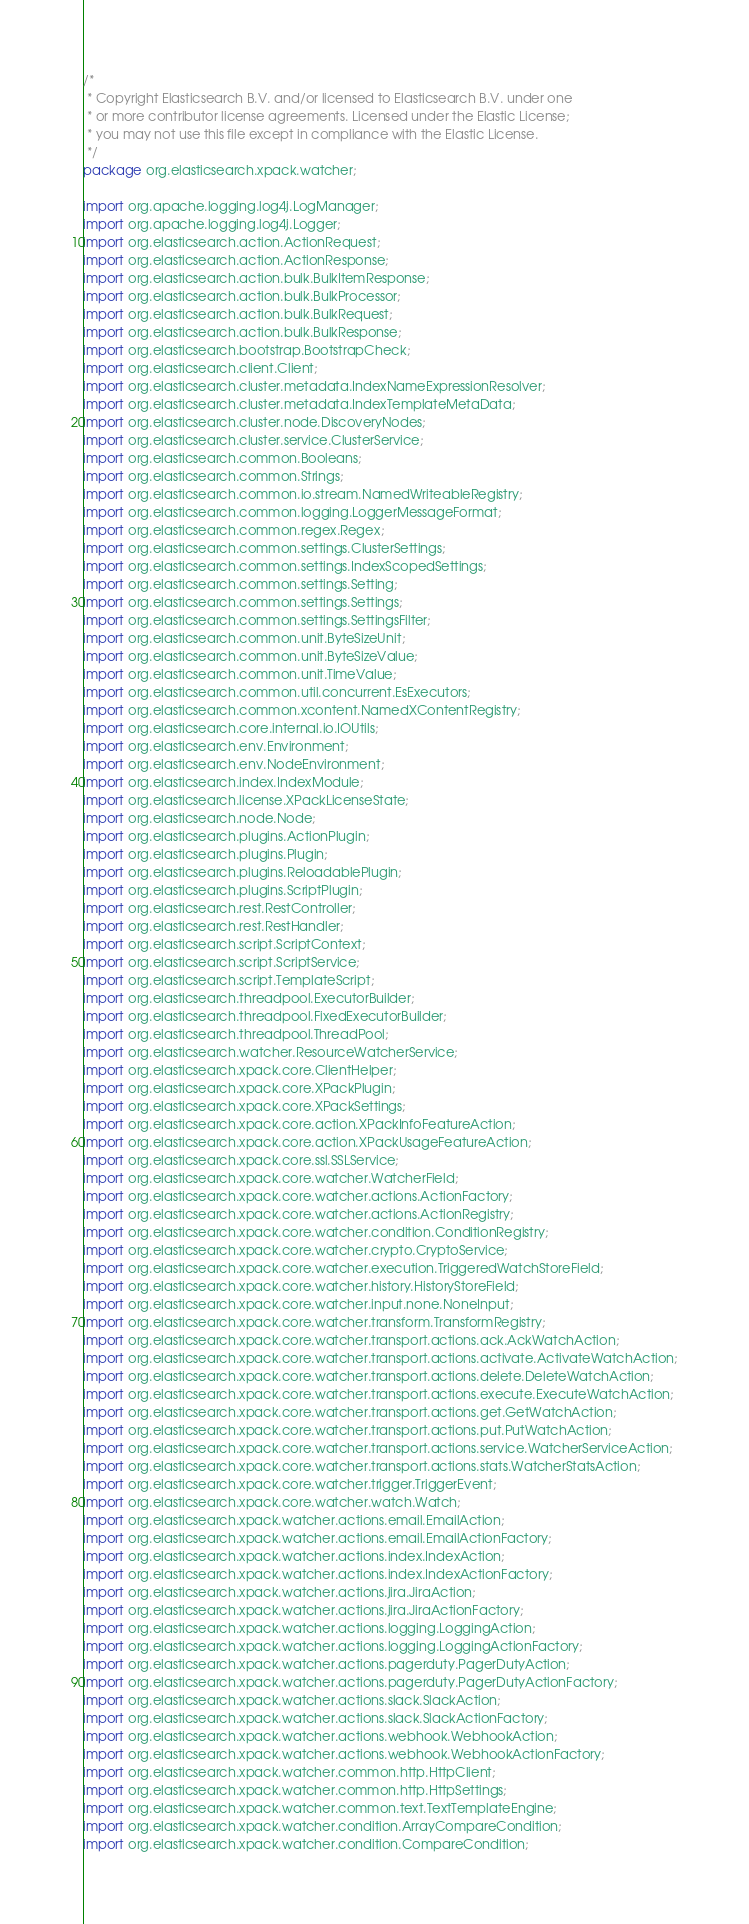Convert code to text. <code><loc_0><loc_0><loc_500><loc_500><_Java_>/*
 * Copyright Elasticsearch B.V. and/or licensed to Elasticsearch B.V. under one
 * or more contributor license agreements. Licensed under the Elastic License;
 * you may not use this file except in compliance with the Elastic License.
 */
package org.elasticsearch.xpack.watcher;

import org.apache.logging.log4j.LogManager;
import org.apache.logging.log4j.Logger;
import org.elasticsearch.action.ActionRequest;
import org.elasticsearch.action.ActionResponse;
import org.elasticsearch.action.bulk.BulkItemResponse;
import org.elasticsearch.action.bulk.BulkProcessor;
import org.elasticsearch.action.bulk.BulkRequest;
import org.elasticsearch.action.bulk.BulkResponse;
import org.elasticsearch.bootstrap.BootstrapCheck;
import org.elasticsearch.client.Client;
import org.elasticsearch.cluster.metadata.IndexNameExpressionResolver;
import org.elasticsearch.cluster.metadata.IndexTemplateMetaData;
import org.elasticsearch.cluster.node.DiscoveryNodes;
import org.elasticsearch.cluster.service.ClusterService;
import org.elasticsearch.common.Booleans;
import org.elasticsearch.common.Strings;
import org.elasticsearch.common.io.stream.NamedWriteableRegistry;
import org.elasticsearch.common.logging.LoggerMessageFormat;
import org.elasticsearch.common.regex.Regex;
import org.elasticsearch.common.settings.ClusterSettings;
import org.elasticsearch.common.settings.IndexScopedSettings;
import org.elasticsearch.common.settings.Setting;
import org.elasticsearch.common.settings.Settings;
import org.elasticsearch.common.settings.SettingsFilter;
import org.elasticsearch.common.unit.ByteSizeUnit;
import org.elasticsearch.common.unit.ByteSizeValue;
import org.elasticsearch.common.unit.TimeValue;
import org.elasticsearch.common.util.concurrent.EsExecutors;
import org.elasticsearch.common.xcontent.NamedXContentRegistry;
import org.elasticsearch.core.internal.io.IOUtils;
import org.elasticsearch.env.Environment;
import org.elasticsearch.env.NodeEnvironment;
import org.elasticsearch.index.IndexModule;
import org.elasticsearch.license.XPackLicenseState;
import org.elasticsearch.node.Node;
import org.elasticsearch.plugins.ActionPlugin;
import org.elasticsearch.plugins.Plugin;
import org.elasticsearch.plugins.ReloadablePlugin;
import org.elasticsearch.plugins.ScriptPlugin;
import org.elasticsearch.rest.RestController;
import org.elasticsearch.rest.RestHandler;
import org.elasticsearch.script.ScriptContext;
import org.elasticsearch.script.ScriptService;
import org.elasticsearch.script.TemplateScript;
import org.elasticsearch.threadpool.ExecutorBuilder;
import org.elasticsearch.threadpool.FixedExecutorBuilder;
import org.elasticsearch.threadpool.ThreadPool;
import org.elasticsearch.watcher.ResourceWatcherService;
import org.elasticsearch.xpack.core.ClientHelper;
import org.elasticsearch.xpack.core.XPackPlugin;
import org.elasticsearch.xpack.core.XPackSettings;
import org.elasticsearch.xpack.core.action.XPackInfoFeatureAction;
import org.elasticsearch.xpack.core.action.XPackUsageFeatureAction;
import org.elasticsearch.xpack.core.ssl.SSLService;
import org.elasticsearch.xpack.core.watcher.WatcherField;
import org.elasticsearch.xpack.core.watcher.actions.ActionFactory;
import org.elasticsearch.xpack.core.watcher.actions.ActionRegistry;
import org.elasticsearch.xpack.core.watcher.condition.ConditionRegistry;
import org.elasticsearch.xpack.core.watcher.crypto.CryptoService;
import org.elasticsearch.xpack.core.watcher.execution.TriggeredWatchStoreField;
import org.elasticsearch.xpack.core.watcher.history.HistoryStoreField;
import org.elasticsearch.xpack.core.watcher.input.none.NoneInput;
import org.elasticsearch.xpack.core.watcher.transform.TransformRegistry;
import org.elasticsearch.xpack.core.watcher.transport.actions.ack.AckWatchAction;
import org.elasticsearch.xpack.core.watcher.transport.actions.activate.ActivateWatchAction;
import org.elasticsearch.xpack.core.watcher.transport.actions.delete.DeleteWatchAction;
import org.elasticsearch.xpack.core.watcher.transport.actions.execute.ExecuteWatchAction;
import org.elasticsearch.xpack.core.watcher.transport.actions.get.GetWatchAction;
import org.elasticsearch.xpack.core.watcher.transport.actions.put.PutWatchAction;
import org.elasticsearch.xpack.core.watcher.transport.actions.service.WatcherServiceAction;
import org.elasticsearch.xpack.core.watcher.transport.actions.stats.WatcherStatsAction;
import org.elasticsearch.xpack.core.watcher.trigger.TriggerEvent;
import org.elasticsearch.xpack.core.watcher.watch.Watch;
import org.elasticsearch.xpack.watcher.actions.email.EmailAction;
import org.elasticsearch.xpack.watcher.actions.email.EmailActionFactory;
import org.elasticsearch.xpack.watcher.actions.index.IndexAction;
import org.elasticsearch.xpack.watcher.actions.index.IndexActionFactory;
import org.elasticsearch.xpack.watcher.actions.jira.JiraAction;
import org.elasticsearch.xpack.watcher.actions.jira.JiraActionFactory;
import org.elasticsearch.xpack.watcher.actions.logging.LoggingAction;
import org.elasticsearch.xpack.watcher.actions.logging.LoggingActionFactory;
import org.elasticsearch.xpack.watcher.actions.pagerduty.PagerDutyAction;
import org.elasticsearch.xpack.watcher.actions.pagerduty.PagerDutyActionFactory;
import org.elasticsearch.xpack.watcher.actions.slack.SlackAction;
import org.elasticsearch.xpack.watcher.actions.slack.SlackActionFactory;
import org.elasticsearch.xpack.watcher.actions.webhook.WebhookAction;
import org.elasticsearch.xpack.watcher.actions.webhook.WebhookActionFactory;
import org.elasticsearch.xpack.watcher.common.http.HttpClient;
import org.elasticsearch.xpack.watcher.common.http.HttpSettings;
import org.elasticsearch.xpack.watcher.common.text.TextTemplateEngine;
import org.elasticsearch.xpack.watcher.condition.ArrayCompareCondition;
import org.elasticsearch.xpack.watcher.condition.CompareCondition;</code> 